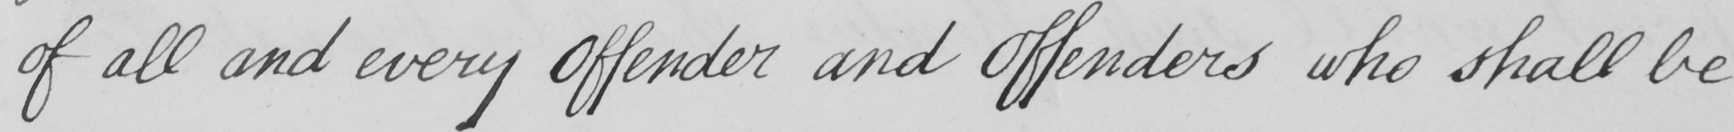What does this handwritten line say? of all and every Offender and Offenders who shall be 